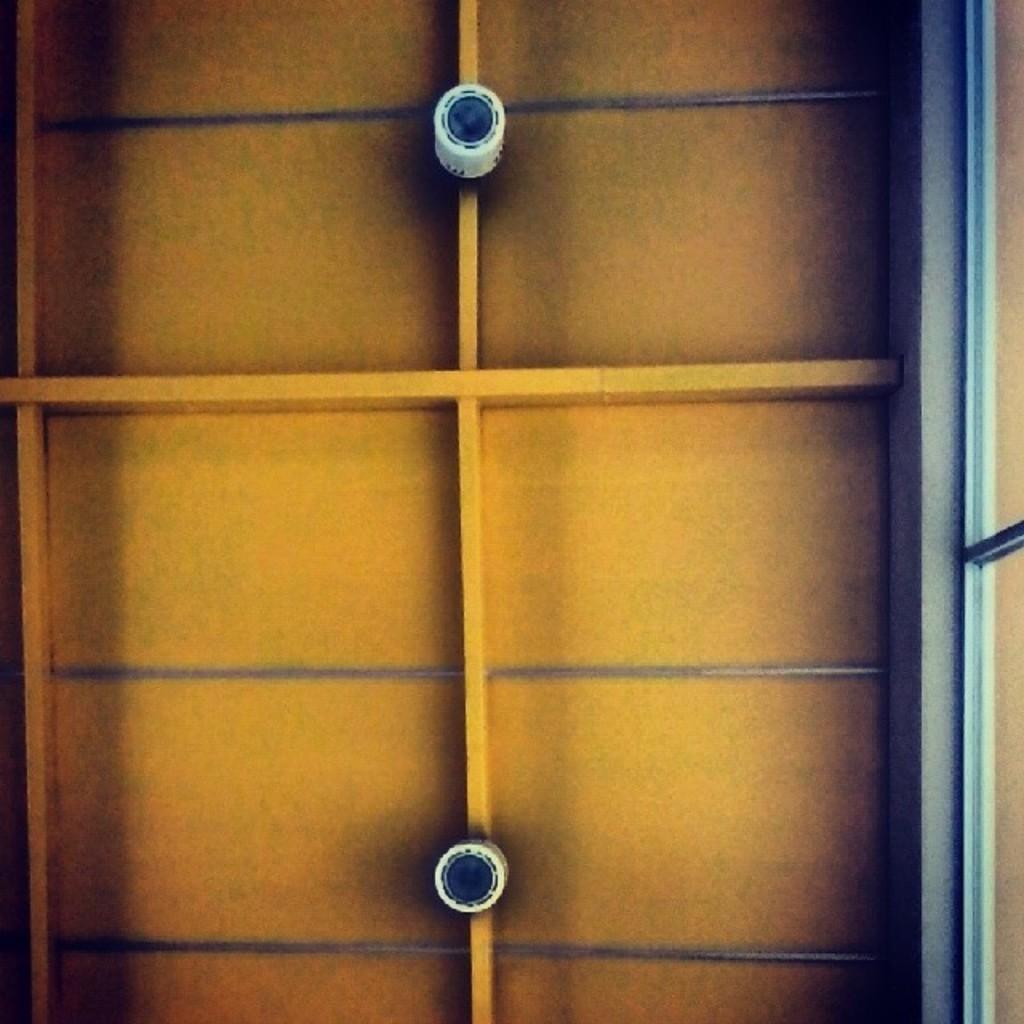Please provide a concise description of this image. This is a picture of a wooden shelf. 